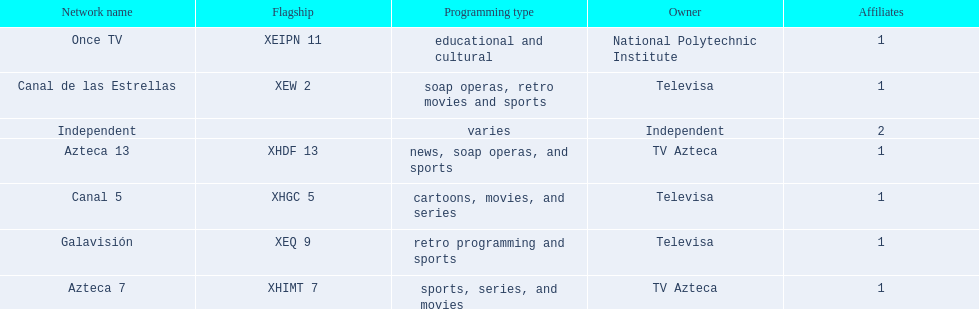What station shows cartoons? Canal 5. What station shows soap operas? Canal de las Estrellas. What station shows sports? Azteca 7. 